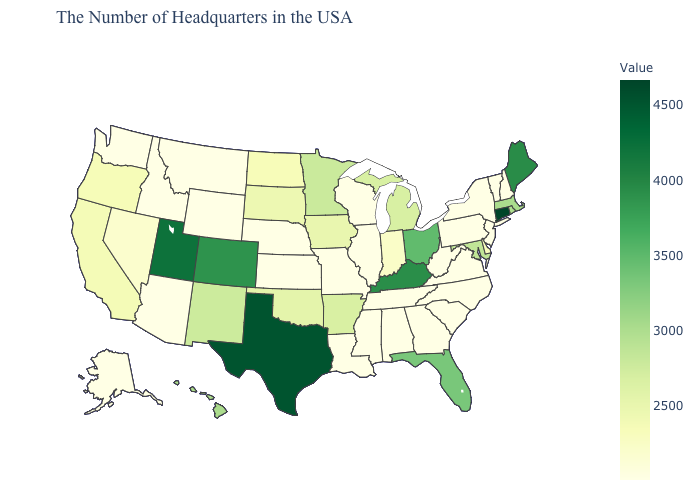Is the legend a continuous bar?
Concise answer only. Yes. Does Florida have the lowest value in the USA?
Short answer required. No. 